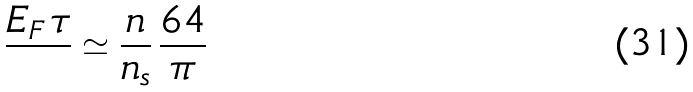Convert formula to latex. <formula><loc_0><loc_0><loc_500><loc_500>\frac { E _ { F } \, \tau } { } \simeq \frac { n } { n _ { s } } \, \frac { 6 4 } { \pi }</formula> 